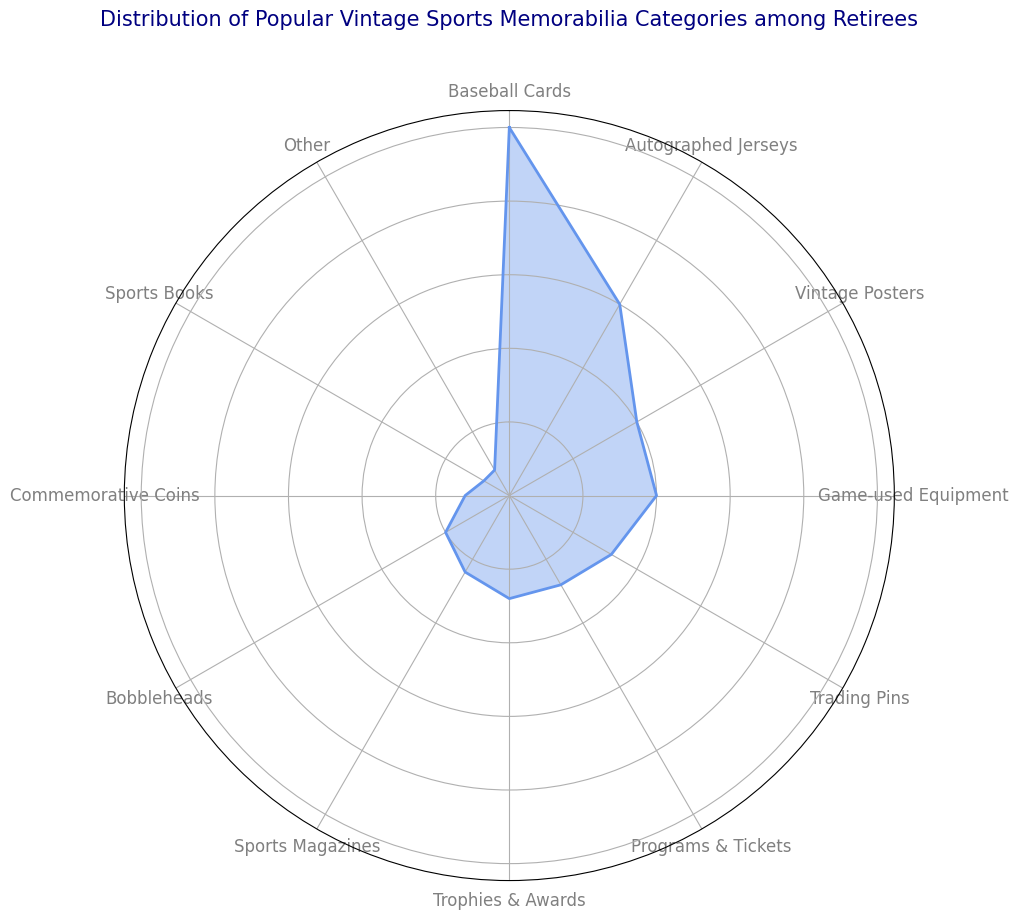What category has the largest percentage of vintage sports memorabilia among retirees? By visually inspecting the length of the sectors in the rose chart, the category "Baseball Cards" has the largest percentage, occupying the most space.
Answer: Baseball Cards Which category has a larger percentage, Sports Magazines or Programs & Tickets? By comparing the lengths of the sectors, Programs & Tickets are longer than Sports Magazines in the rose chart.
Answer: Programs & Tickets How do the percentages of Autographed Jerseys and Vintage Posters combined compare to Baseball Cards? Add the percentages of Autographed Jerseys (15%) and Vintage Posters (10%) to get (15% + 10% = 25%), which is equal to the percentage of Baseball Cards (25%).
Answer: Equal What is the combined percentage for the three categories with the smallest percentages? The three smallest sectors are Sports Books (2%), Other (2%), and Commemorative Coins (3%). Add them up (2% + 2% + 3% = 7%).
Answer: 7% What is the visual difference between the largest and the smallest category in the rose chart? The largest category is Baseball Cards (25%) and the smallest is Sports Books (2%). Visually note the length difference of the sectors, Baseball Cards sector is significantly longer.
Answer: Significant difference Which category comes directly after Game-used Equipment in the clockwise direction? In the rose chart, the order starts from one point and rotates clockwise; the category immediately after Game-used Equipment is Trading Pins.
Answer: Trading Pins Are there more categories with a percentage of 10% or more, or less than 10%? Categories with 10% or more: Baseball Cards, Autographed Jerseys, Vintage Posters, Game-used Equipment. Categories with less than 10%: Trading Pins, Programs & Tickets, Trophies & Awards, Sports Magazines, Bobbleheads, Commemorative Coins, Sports Books, Other. There are 4 with 10%+ and 8 with <10%.
Answer: Less than 10% What is the total percentage of categories related to printed material (Sports Magazines, Sports Books, Programs & Tickets, Vintage Posters)? Sum the percentages: Sports Magazines (6%), Sports Books (2%), Programs & Tickets (7%), Vintage Posters (10%). Total = 6% + 2% + 7% + 10% = 25%.
Answer: 25% Which category has the smallest visual area in the rose chart? By looking for the shortest sector in the chart, Sports Books has the smallest visual area.
Answer: Sports Books 